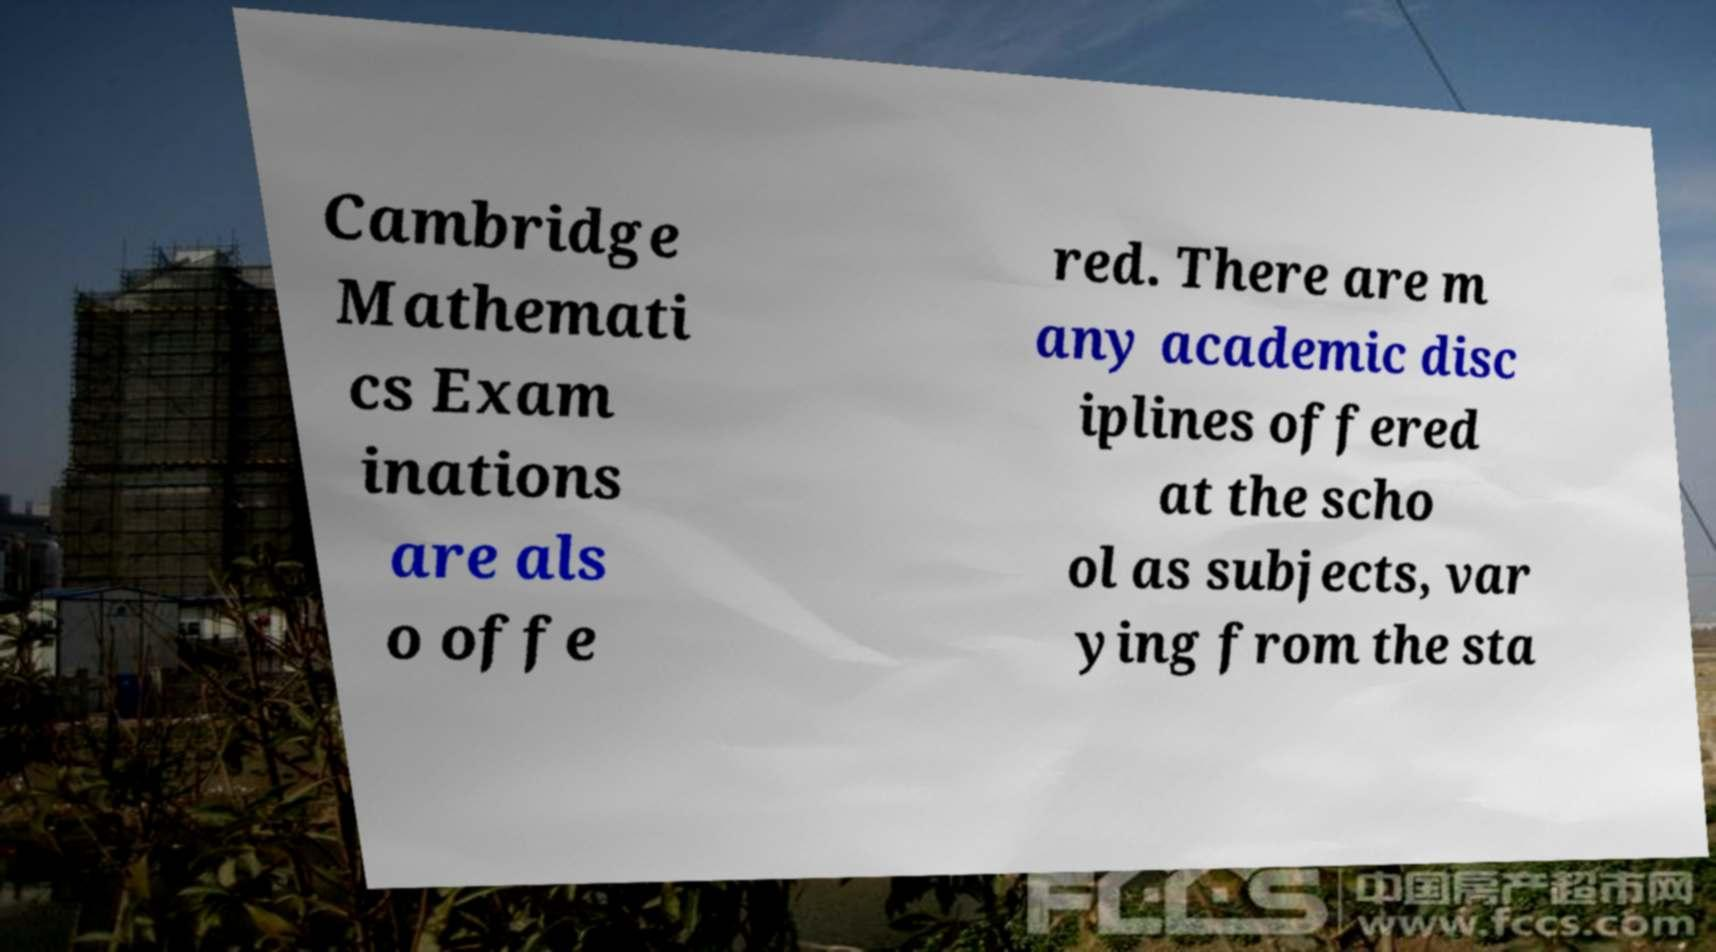I need the written content from this picture converted into text. Can you do that? Cambridge Mathemati cs Exam inations are als o offe red. There are m any academic disc iplines offered at the scho ol as subjects, var ying from the sta 